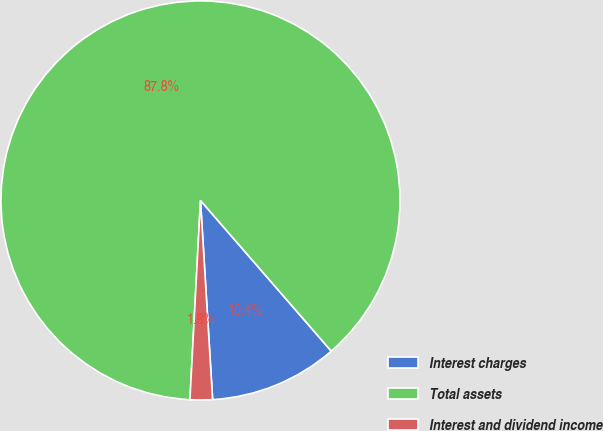<chart> <loc_0><loc_0><loc_500><loc_500><pie_chart><fcel>Interest charges<fcel>Total assets<fcel>Interest and dividend income<nl><fcel>10.41%<fcel>87.78%<fcel>1.81%<nl></chart> 